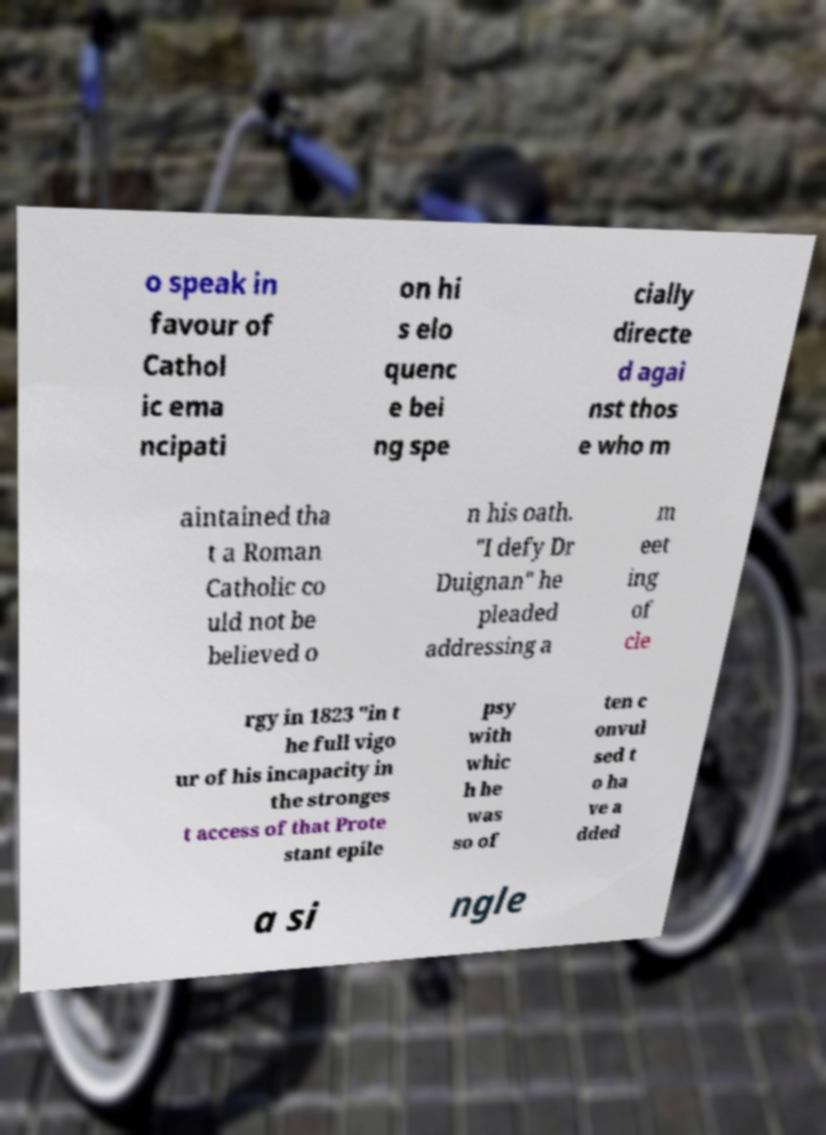There's text embedded in this image that I need extracted. Can you transcribe it verbatim? o speak in favour of Cathol ic ema ncipati on hi s elo quenc e bei ng spe cially directe d agai nst thos e who m aintained tha t a Roman Catholic co uld not be believed o n his oath. "I defy Dr Duignan" he pleaded addressing a m eet ing of cle rgy in 1823 "in t he full vigo ur of his incapacity in the stronges t access of that Prote stant epile psy with whic h he was so of ten c onvul sed t o ha ve a dded a si ngle 